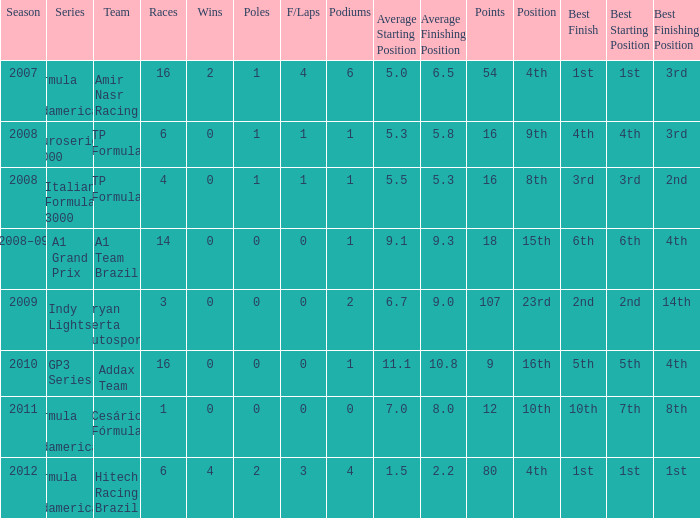What unit did he compete with in the gp3 series? Addax Team. 